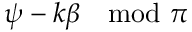<formula> <loc_0><loc_0><loc_500><loc_500>\psi - k \beta \mod \pi</formula> 